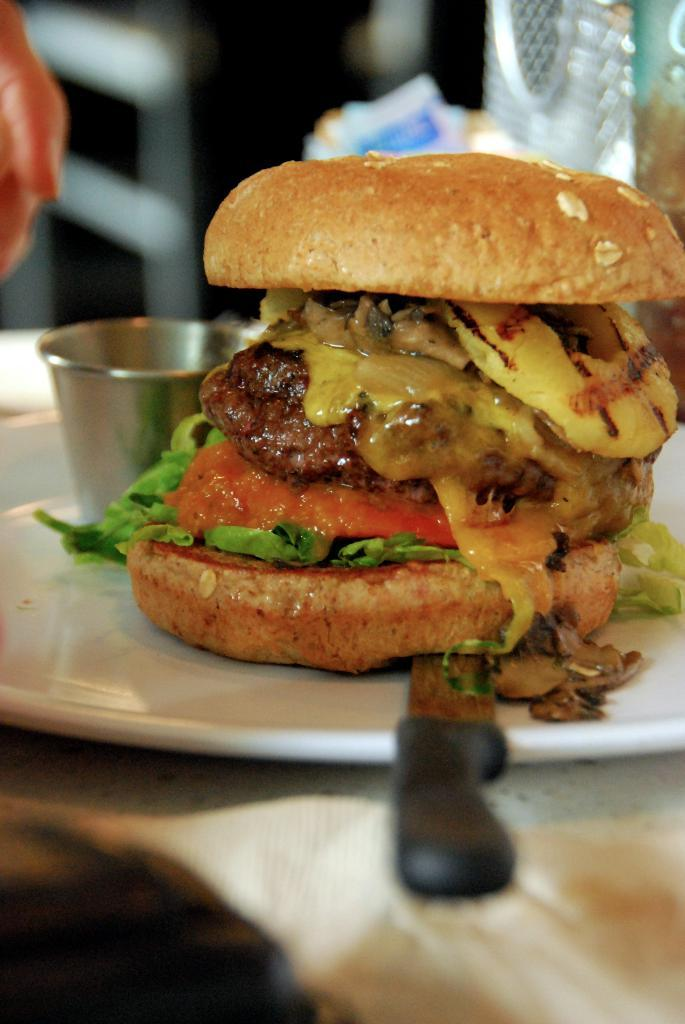What type of food is visible in the image? The food in the image has brown, red, and yellow colors. What color is the plate that the food is on? The plate is white. What other items can be seen in the image besides the food? There is a glass and a knife in the image. Are there any cobwebs visible in the image? No, there are no cobwebs present in the image. Can you see any horses in the image? No, there are no horses present in the image. 